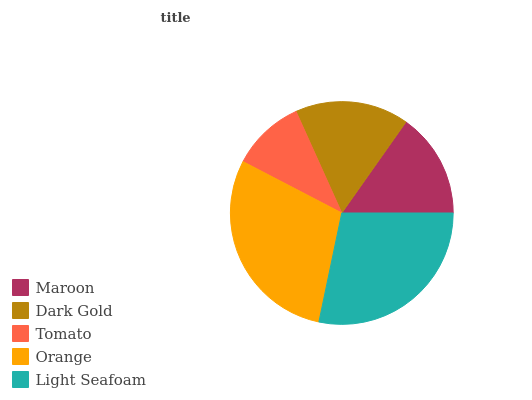Is Tomato the minimum?
Answer yes or no. Yes. Is Orange the maximum?
Answer yes or no. Yes. Is Dark Gold the minimum?
Answer yes or no. No. Is Dark Gold the maximum?
Answer yes or no. No. Is Dark Gold greater than Maroon?
Answer yes or no. Yes. Is Maroon less than Dark Gold?
Answer yes or no. Yes. Is Maroon greater than Dark Gold?
Answer yes or no. No. Is Dark Gold less than Maroon?
Answer yes or no. No. Is Dark Gold the high median?
Answer yes or no. Yes. Is Dark Gold the low median?
Answer yes or no. Yes. Is Light Seafoam the high median?
Answer yes or no. No. Is Maroon the low median?
Answer yes or no. No. 